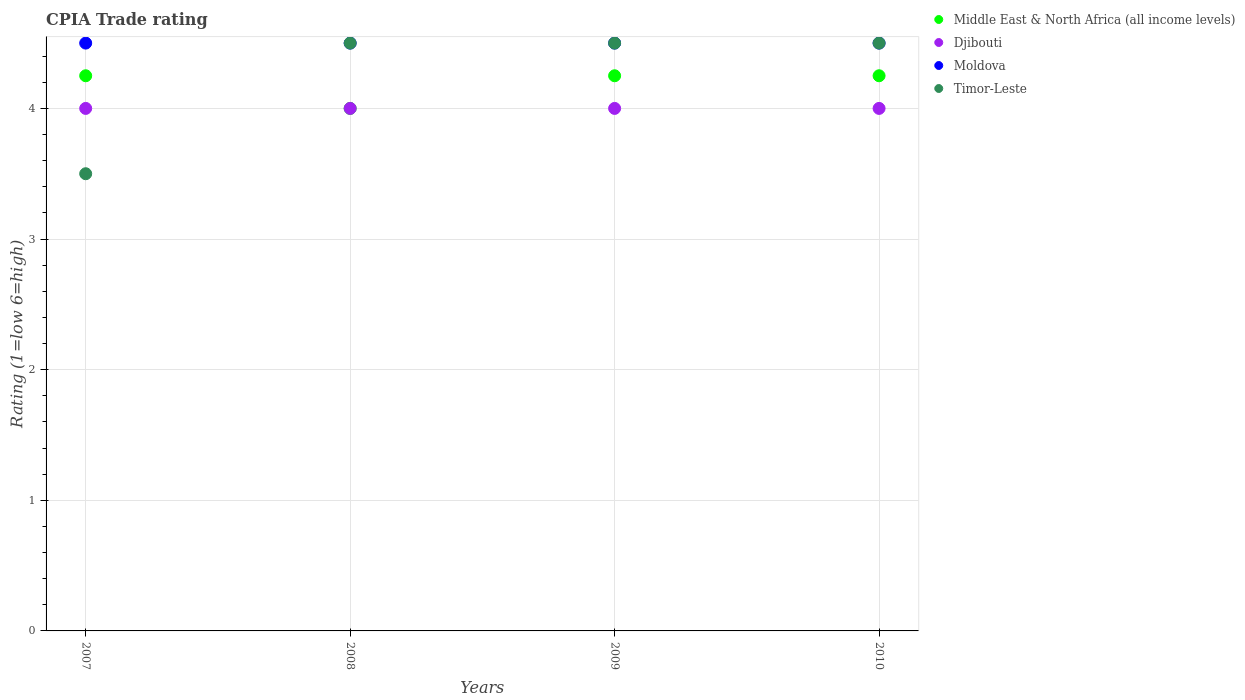Is the number of dotlines equal to the number of legend labels?
Your answer should be very brief. Yes. What is the CPIA rating in Djibouti in 2007?
Offer a terse response. 4. Across all years, what is the maximum CPIA rating in Middle East & North Africa (all income levels)?
Provide a succinct answer. 4.25. Across all years, what is the minimum CPIA rating in Timor-Leste?
Provide a succinct answer. 3.5. In which year was the CPIA rating in Timor-Leste maximum?
Keep it short and to the point. 2008. What is the total CPIA rating in Middle East & North Africa (all income levels) in the graph?
Your response must be concise. 16.75. What is the difference between the CPIA rating in Timor-Leste in 2009 and that in 2010?
Your answer should be very brief. 0. What is the difference between the CPIA rating in Timor-Leste in 2007 and the CPIA rating in Middle East & North Africa (all income levels) in 2010?
Give a very brief answer. -0.75. What is the average CPIA rating in Djibouti per year?
Make the answer very short. 4. In the year 2010, what is the difference between the CPIA rating in Middle East & North Africa (all income levels) and CPIA rating in Timor-Leste?
Offer a terse response. -0.25. What is the ratio of the CPIA rating in Timor-Leste in 2008 to that in 2010?
Provide a succinct answer. 1. Is the CPIA rating in Timor-Leste in 2007 less than that in 2009?
Your response must be concise. Yes. Is the difference between the CPIA rating in Middle East & North Africa (all income levels) in 2009 and 2010 greater than the difference between the CPIA rating in Timor-Leste in 2009 and 2010?
Provide a short and direct response. No. What is the difference between the highest and the second highest CPIA rating in Middle East & North Africa (all income levels)?
Keep it short and to the point. 0. Is it the case that in every year, the sum of the CPIA rating in Timor-Leste and CPIA rating in Djibouti  is greater than the CPIA rating in Middle East & North Africa (all income levels)?
Provide a succinct answer. Yes. Does the CPIA rating in Middle East & North Africa (all income levels) monotonically increase over the years?
Make the answer very short. No. Is the CPIA rating in Middle East & North Africa (all income levels) strictly greater than the CPIA rating in Timor-Leste over the years?
Give a very brief answer. No. Is the CPIA rating in Moldova strictly less than the CPIA rating in Timor-Leste over the years?
Your answer should be compact. No. How many years are there in the graph?
Offer a very short reply. 4. Are the values on the major ticks of Y-axis written in scientific E-notation?
Your answer should be compact. No. Does the graph contain any zero values?
Your answer should be very brief. No. Does the graph contain grids?
Provide a succinct answer. Yes. Where does the legend appear in the graph?
Ensure brevity in your answer.  Top right. How many legend labels are there?
Your answer should be compact. 4. What is the title of the graph?
Provide a succinct answer. CPIA Trade rating. Does "Niger" appear as one of the legend labels in the graph?
Provide a short and direct response. No. What is the label or title of the X-axis?
Your response must be concise. Years. What is the Rating (1=low 6=high) in Middle East & North Africa (all income levels) in 2007?
Provide a succinct answer. 4.25. What is the Rating (1=low 6=high) of Djibouti in 2007?
Keep it short and to the point. 4. What is the Rating (1=low 6=high) in Timor-Leste in 2007?
Offer a very short reply. 3.5. What is the Rating (1=low 6=high) in Djibouti in 2008?
Give a very brief answer. 4. What is the Rating (1=low 6=high) in Middle East & North Africa (all income levels) in 2009?
Give a very brief answer. 4.25. What is the Rating (1=low 6=high) of Djibouti in 2009?
Offer a very short reply. 4. What is the Rating (1=low 6=high) in Middle East & North Africa (all income levels) in 2010?
Provide a succinct answer. 4.25. What is the Rating (1=low 6=high) of Djibouti in 2010?
Provide a short and direct response. 4. What is the Rating (1=low 6=high) in Moldova in 2010?
Offer a terse response. 4.5. What is the Rating (1=low 6=high) in Timor-Leste in 2010?
Keep it short and to the point. 4.5. Across all years, what is the maximum Rating (1=low 6=high) of Middle East & North Africa (all income levels)?
Provide a succinct answer. 4.25. Across all years, what is the maximum Rating (1=low 6=high) in Timor-Leste?
Ensure brevity in your answer.  4.5. Across all years, what is the minimum Rating (1=low 6=high) of Djibouti?
Provide a succinct answer. 4. Across all years, what is the minimum Rating (1=low 6=high) in Moldova?
Your answer should be very brief. 4.5. Across all years, what is the minimum Rating (1=low 6=high) of Timor-Leste?
Provide a succinct answer. 3.5. What is the total Rating (1=low 6=high) in Middle East & North Africa (all income levels) in the graph?
Give a very brief answer. 16.75. What is the total Rating (1=low 6=high) in Moldova in the graph?
Make the answer very short. 18. What is the total Rating (1=low 6=high) of Timor-Leste in the graph?
Offer a very short reply. 17. What is the difference between the Rating (1=low 6=high) in Djibouti in 2007 and that in 2008?
Make the answer very short. 0. What is the difference between the Rating (1=low 6=high) in Moldova in 2007 and that in 2008?
Your response must be concise. 0. What is the difference between the Rating (1=low 6=high) of Moldova in 2007 and that in 2010?
Make the answer very short. 0. What is the difference between the Rating (1=low 6=high) in Timor-Leste in 2007 and that in 2010?
Offer a very short reply. -1. What is the difference between the Rating (1=low 6=high) in Middle East & North Africa (all income levels) in 2008 and that in 2009?
Offer a terse response. -0.25. What is the difference between the Rating (1=low 6=high) in Djibouti in 2008 and that in 2009?
Ensure brevity in your answer.  0. What is the difference between the Rating (1=low 6=high) in Middle East & North Africa (all income levels) in 2008 and that in 2010?
Keep it short and to the point. -0.25. What is the difference between the Rating (1=low 6=high) in Djibouti in 2008 and that in 2010?
Offer a terse response. 0. What is the difference between the Rating (1=low 6=high) of Moldova in 2008 and that in 2010?
Offer a very short reply. 0. What is the difference between the Rating (1=low 6=high) in Middle East & North Africa (all income levels) in 2009 and that in 2010?
Keep it short and to the point. 0. What is the difference between the Rating (1=low 6=high) in Djibouti in 2009 and that in 2010?
Provide a short and direct response. 0. What is the difference between the Rating (1=low 6=high) of Timor-Leste in 2009 and that in 2010?
Provide a short and direct response. 0. What is the difference between the Rating (1=low 6=high) in Middle East & North Africa (all income levels) in 2007 and the Rating (1=low 6=high) in Djibouti in 2008?
Offer a very short reply. 0.25. What is the difference between the Rating (1=low 6=high) of Middle East & North Africa (all income levels) in 2007 and the Rating (1=low 6=high) of Timor-Leste in 2008?
Offer a terse response. -0.25. What is the difference between the Rating (1=low 6=high) in Djibouti in 2007 and the Rating (1=low 6=high) in Moldova in 2008?
Your answer should be very brief. -0.5. What is the difference between the Rating (1=low 6=high) of Moldova in 2007 and the Rating (1=low 6=high) of Timor-Leste in 2008?
Your answer should be compact. 0. What is the difference between the Rating (1=low 6=high) of Middle East & North Africa (all income levels) in 2007 and the Rating (1=low 6=high) of Timor-Leste in 2009?
Make the answer very short. -0.25. What is the difference between the Rating (1=low 6=high) of Djibouti in 2007 and the Rating (1=low 6=high) of Moldova in 2009?
Offer a very short reply. -0.5. What is the difference between the Rating (1=low 6=high) of Djibouti in 2007 and the Rating (1=low 6=high) of Timor-Leste in 2009?
Make the answer very short. -0.5. What is the difference between the Rating (1=low 6=high) in Middle East & North Africa (all income levels) in 2007 and the Rating (1=low 6=high) in Djibouti in 2010?
Offer a very short reply. 0.25. What is the difference between the Rating (1=low 6=high) in Middle East & North Africa (all income levels) in 2007 and the Rating (1=low 6=high) in Timor-Leste in 2010?
Provide a succinct answer. -0.25. What is the difference between the Rating (1=low 6=high) of Djibouti in 2007 and the Rating (1=low 6=high) of Moldova in 2010?
Your response must be concise. -0.5. What is the difference between the Rating (1=low 6=high) in Moldova in 2007 and the Rating (1=low 6=high) in Timor-Leste in 2010?
Ensure brevity in your answer.  0. What is the difference between the Rating (1=low 6=high) of Middle East & North Africa (all income levels) in 2008 and the Rating (1=low 6=high) of Djibouti in 2009?
Keep it short and to the point. 0. What is the difference between the Rating (1=low 6=high) of Middle East & North Africa (all income levels) in 2008 and the Rating (1=low 6=high) of Moldova in 2009?
Your response must be concise. -0.5. What is the difference between the Rating (1=low 6=high) of Moldova in 2008 and the Rating (1=low 6=high) of Timor-Leste in 2009?
Give a very brief answer. 0. What is the difference between the Rating (1=low 6=high) of Middle East & North Africa (all income levels) in 2008 and the Rating (1=low 6=high) of Djibouti in 2010?
Give a very brief answer. 0. What is the difference between the Rating (1=low 6=high) in Middle East & North Africa (all income levels) in 2009 and the Rating (1=low 6=high) in Timor-Leste in 2010?
Keep it short and to the point. -0.25. What is the difference between the Rating (1=low 6=high) of Djibouti in 2009 and the Rating (1=low 6=high) of Moldova in 2010?
Offer a terse response. -0.5. What is the difference between the Rating (1=low 6=high) in Djibouti in 2009 and the Rating (1=low 6=high) in Timor-Leste in 2010?
Ensure brevity in your answer.  -0.5. What is the difference between the Rating (1=low 6=high) in Moldova in 2009 and the Rating (1=low 6=high) in Timor-Leste in 2010?
Make the answer very short. 0. What is the average Rating (1=low 6=high) in Middle East & North Africa (all income levels) per year?
Provide a succinct answer. 4.19. What is the average Rating (1=low 6=high) in Djibouti per year?
Your response must be concise. 4. What is the average Rating (1=low 6=high) of Timor-Leste per year?
Offer a very short reply. 4.25. In the year 2007, what is the difference between the Rating (1=low 6=high) in Middle East & North Africa (all income levels) and Rating (1=low 6=high) in Moldova?
Your answer should be very brief. -0.25. In the year 2007, what is the difference between the Rating (1=low 6=high) of Middle East & North Africa (all income levels) and Rating (1=low 6=high) of Timor-Leste?
Give a very brief answer. 0.75. In the year 2007, what is the difference between the Rating (1=low 6=high) in Moldova and Rating (1=low 6=high) in Timor-Leste?
Your answer should be compact. 1. In the year 2009, what is the difference between the Rating (1=low 6=high) of Middle East & North Africa (all income levels) and Rating (1=low 6=high) of Djibouti?
Give a very brief answer. 0.25. In the year 2009, what is the difference between the Rating (1=low 6=high) in Middle East & North Africa (all income levels) and Rating (1=low 6=high) in Timor-Leste?
Ensure brevity in your answer.  -0.25. In the year 2009, what is the difference between the Rating (1=low 6=high) in Djibouti and Rating (1=low 6=high) in Moldova?
Keep it short and to the point. -0.5. In the year 2009, what is the difference between the Rating (1=low 6=high) of Djibouti and Rating (1=low 6=high) of Timor-Leste?
Give a very brief answer. -0.5. In the year 2010, what is the difference between the Rating (1=low 6=high) in Middle East & North Africa (all income levels) and Rating (1=low 6=high) in Moldova?
Give a very brief answer. -0.25. What is the ratio of the Rating (1=low 6=high) in Middle East & North Africa (all income levels) in 2007 to that in 2008?
Keep it short and to the point. 1.06. What is the ratio of the Rating (1=low 6=high) of Middle East & North Africa (all income levels) in 2007 to that in 2009?
Give a very brief answer. 1. What is the ratio of the Rating (1=low 6=high) in Djibouti in 2007 to that in 2009?
Ensure brevity in your answer.  1. What is the ratio of the Rating (1=low 6=high) in Moldova in 2007 to that in 2009?
Make the answer very short. 1. What is the ratio of the Rating (1=low 6=high) in Middle East & North Africa (all income levels) in 2007 to that in 2010?
Provide a short and direct response. 1. What is the ratio of the Rating (1=low 6=high) in Middle East & North Africa (all income levels) in 2008 to that in 2010?
Ensure brevity in your answer.  0.94. What is the ratio of the Rating (1=low 6=high) of Djibouti in 2008 to that in 2010?
Make the answer very short. 1. What is the ratio of the Rating (1=low 6=high) of Timor-Leste in 2008 to that in 2010?
Ensure brevity in your answer.  1. What is the ratio of the Rating (1=low 6=high) of Middle East & North Africa (all income levels) in 2009 to that in 2010?
Provide a succinct answer. 1. What is the ratio of the Rating (1=low 6=high) in Djibouti in 2009 to that in 2010?
Your answer should be compact. 1. What is the ratio of the Rating (1=low 6=high) of Moldova in 2009 to that in 2010?
Your answer should be very brief. 1. What is the difference between the highest and the second highest Rating (1=low 6=high) in Middle East & North Africa (all income levels)?
Provide a succinct answer. 0. What is the difference between the highest and the lowest Rating (1=low 6=high) of Middle East & North Africa (all income levels)?
Make the answer very short. 0.25. What is the difference between the highest and the lowest Rating (1=low 6=high) in Djibouti?
Provide a succinct answer. 0. What is the difference between the highest and the lowest Rating (1=low 6=high) of Moldova?
Provide a short and direct response. 0. What is the difference between the highest and the lowest Rating (1=low 6=high) of Timor-Leste?
Keep it short and to the point. 1. 